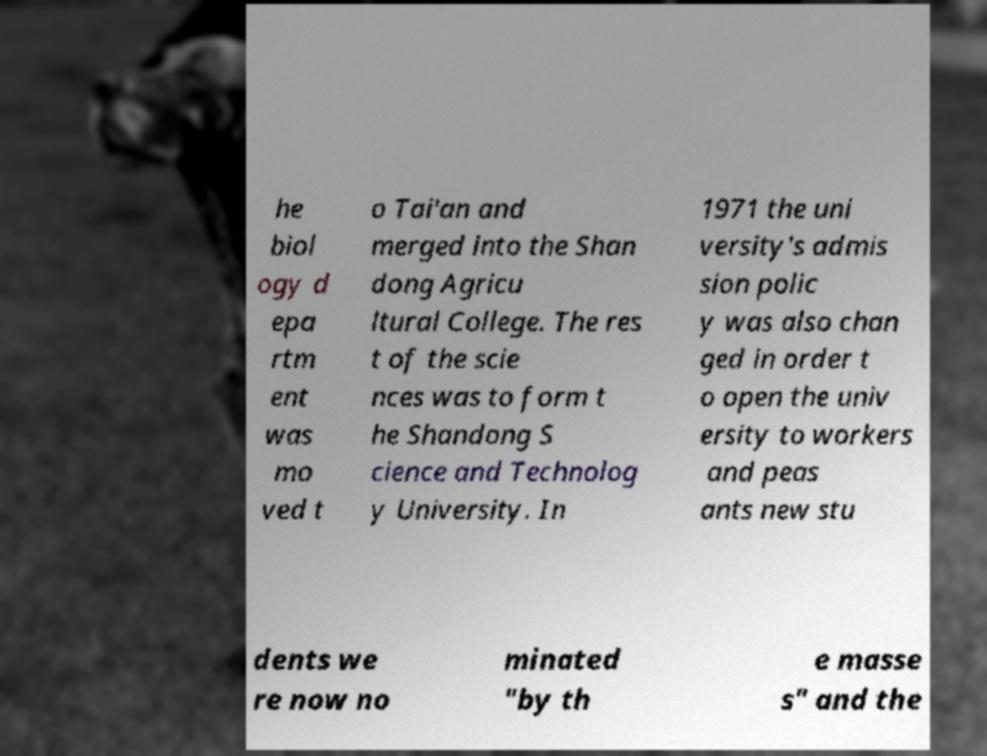Please read and relay the text visible in this image. What does it say? he biol ogy d epa rtm ent was mo ved t o Tai'an and merged into the Shan dong Agricu ltural College. The res t of the scie nces was to form t he Shandong S cience and Technolog y University. In 1971 the uni versity's admis sion polic y was also chan ged in order t o open the univ ersity to workers and peas ants new stu dents we re now no minated "by th e masse s" and the 